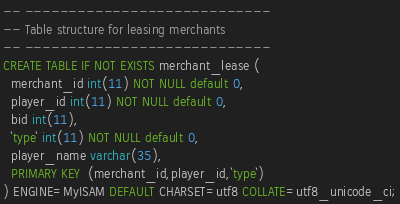<code> <loc_0><loc_0><loc_500><loc_500><_SQL_>-- ----------------------------
-- Table structure for leasing merchants
-- ----------------------------
CREATE TABLE IF NOT EXISTS merchant_lease (
  merchant_id int(11) NOT NULL default 0,
  player_id int(11) NOT NULL default 0,
  bid int(11),
  `type` int(11) NOT NULL default 0,
  player_name varchar(35),
  PRIMARY KEY  (merchant_id,player_id,`type`)
) ENGINE=MyISAM DEFAULT CHARSET=utf8 COLLATE=utf8_unicode_ci;</code> 